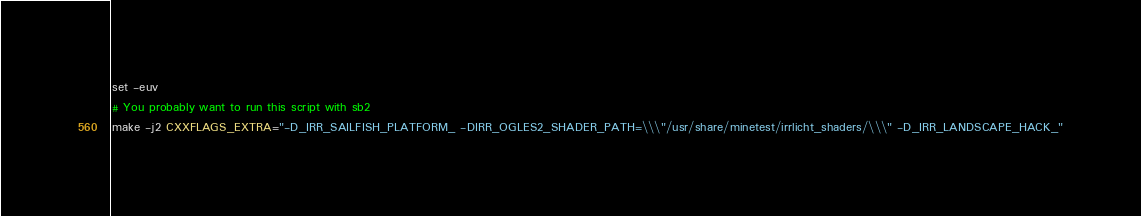<code> <loc_0><loc_0><loc_500><loc_500><_Bash_>set -euv
# You probably want to run this script with sb2
make -j2 CXXFLAGS_EXTRA="-D_IRR_SAILFISH_PLATFORM_ -DIRR_OGLES2_SHADER_PATH=\\\"/usr/share/minetest/irrlicht_shaders/\\\" -D_IRR_LANDSCAPE_HACK_"

</code> 